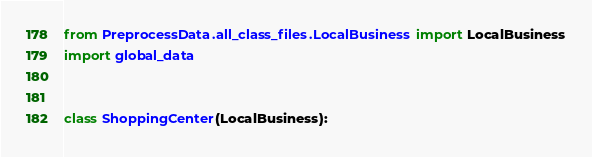Convert code to text. <code><loc_0><loc_0><loc_500><loc_500><_Python_>from PreprocessData.all_class_files.LocalBusiness import LocalBusiness
import global_data


class ShoppingCenter(LocalBusiness):</code> 